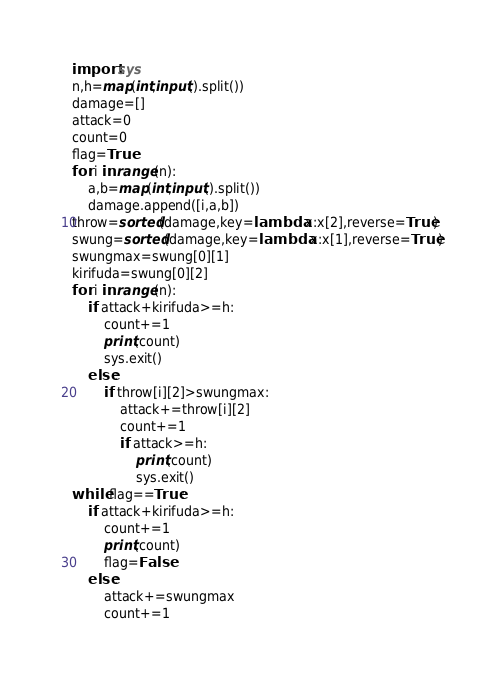Convert code to text. <code><loc_0><loc_0><loc_500><loc_500><_Python_>import sys
n,h=map(int,input().split())
damage=[]
attack=0
count=0
flag=True
for i in range(n):
    a,b=map(int,input().split())
    damage.append([i,a,b])
throw=sorted(damage,key=lambda x:x[2],reverse=True)
swung=sorted(damage,key=lambda x:x[1],reverse=True)
swungmax=swung[0][1]
kirifuda=swung[0][2]
for i in range(n):
    if attack+kirifuda>=h:
        count+=1
        print(count)
        sys.exit()
    else:
        if throw[i][2]>swungmax:
            attack+=throw[i][2]
            count+=1
            if attack>=h:
                print(count)
                sys.exit()
while flag==True:
    if attack+kirifuda>=h:
        count+=1
        print(count)
        flag=False
    else:
        attack+=swungmax
        count+=1
</code> 